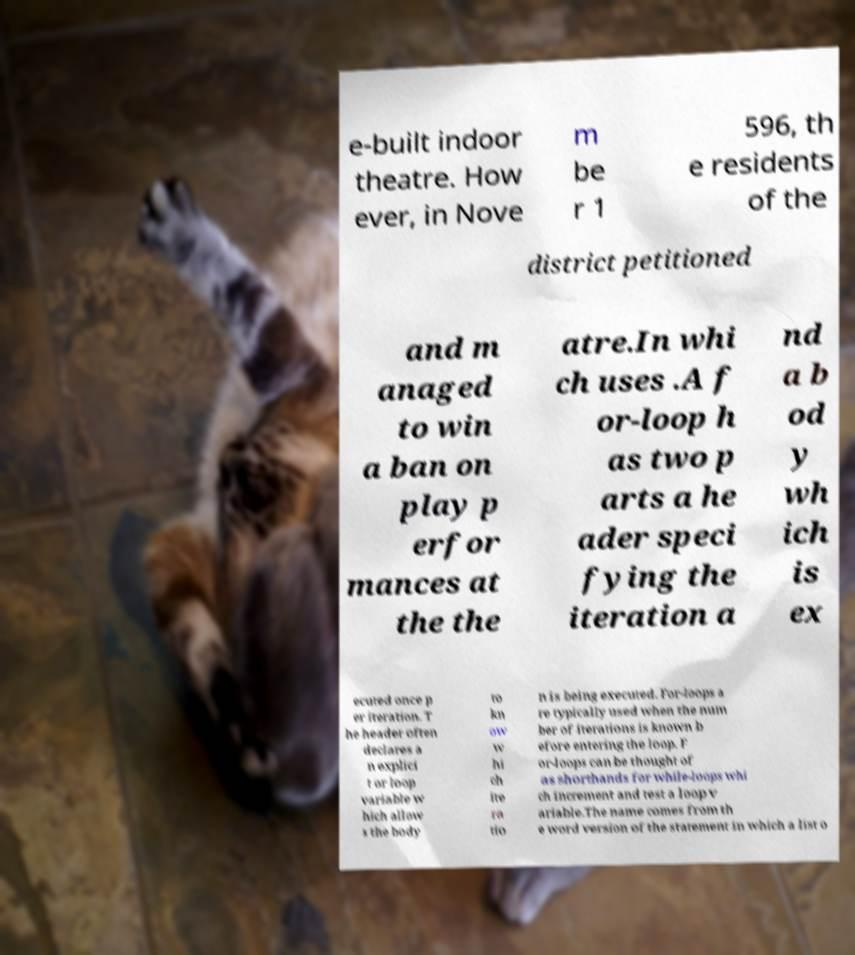There's text embedded in this image that I need extracted. Can you transcribe it verbatim? e-built indoor theatre. How ever, in Nove m be r 1 596, th e residents of the district petitioned and m anaged to win a ban on play p erfor mances at the the atre.In whi ch uses .A f or-loop h as two p arts a he ader speci fying the iteration a nd a b od y wh ich is ex ecuted once p er iteration. T he header often declares a n explici t or loop variable w hich allow s the body to kn ow w hi ch ite ra tio n is being executed. For-loops a re typically used when the num ber of iterations is known b efore entering the loop. F or-loops can be thought of as shorthands for while-loops whi ch increment and test a loop v ariable.The name comes from th e word version of the statement in which a list o 